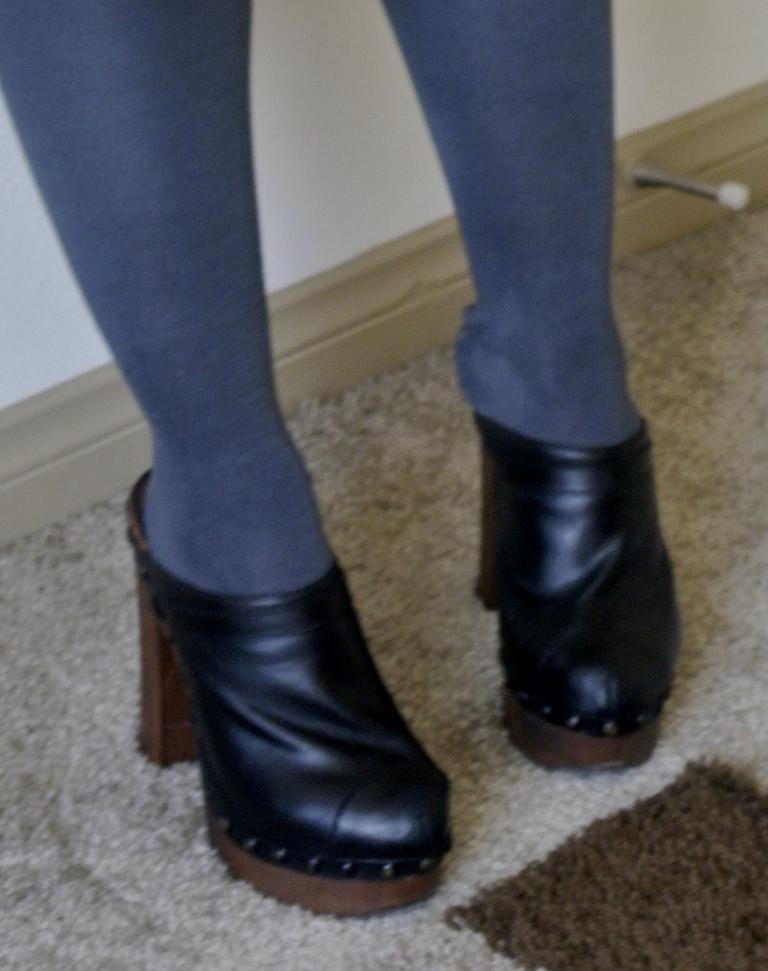What body part is visible in the image? There are a person's legs in the image. What type of footwear is the person wearing? The person is wearing socks and heels. What is on the floor in the image? There is a carpet on the floor in the image. What can be seen in the background of the image? There is a wall visible in the image. What type of jelly is being sold in the shop depicted in the image? There is no shop or jelly present in the image; it only shows a person's legs, their footwear, a carpet, and a wall. 